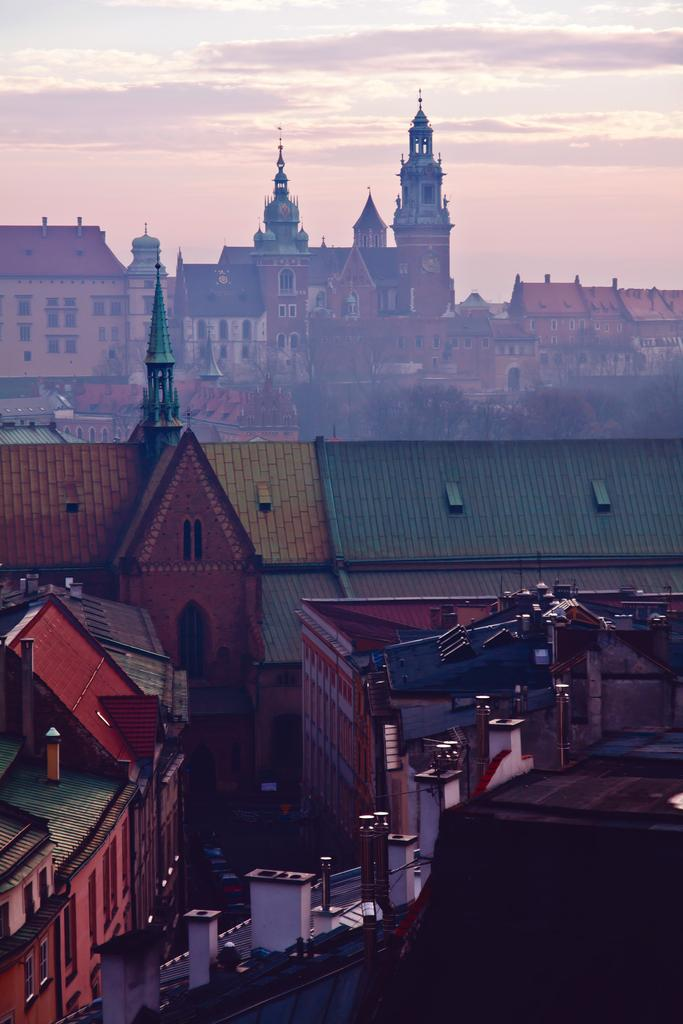What type of structures can be seen in the image? There are houses in the image. What colors are the houses? The houses have various colors, including green, yellow, red, brown, and white. What can be seen in the background of the image? There are clouds and the sky visible in the background of the image. Where is the arm of the giant located in the image? There are no giants or arms present in the image; it features houses with various colors and a background of clouds and the sky. 